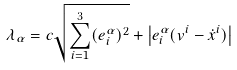<formula> <loc_0><loc_0><loc_500><loc_500>\lambda _ { \alpha } = c \sqrt { \sum _ { i = 1 } ^ { 3 } ( e ^ { \alpha } _ { i } ) ^ { 2 } } + \left | e ^ { \alpha } _ { i } ( v ^ { i } - \dot { x } ^ { i } ) \right |</formula> 